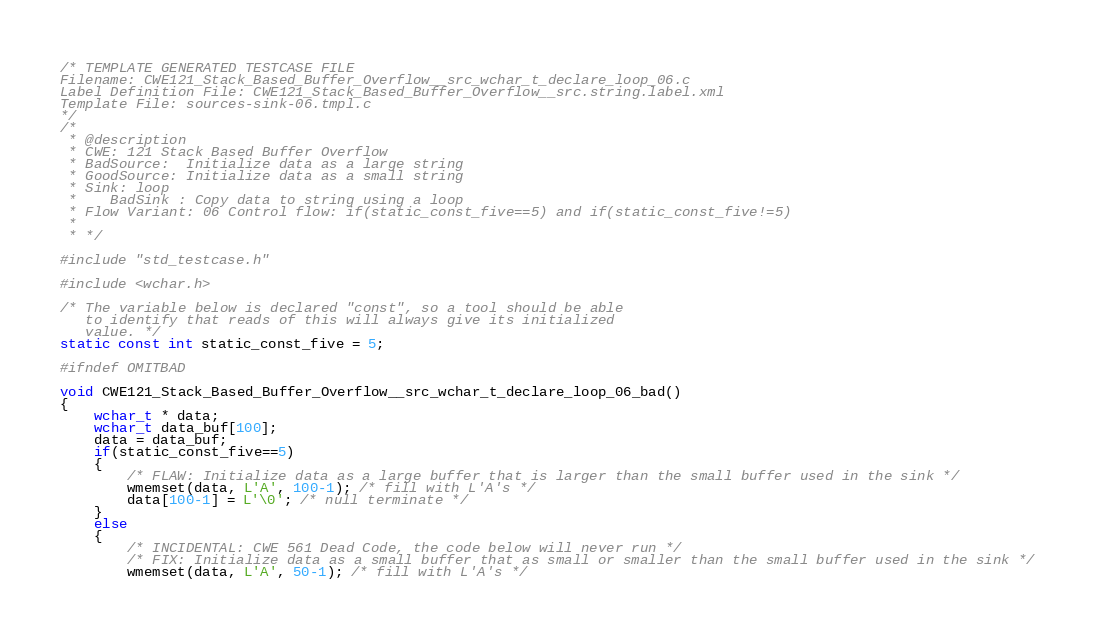<code> <loc_0><loc_0><loc_500><loc_500><_C_>/* TEMPLATE GENERATED TESTCASE FILE
Filename: CWE121_Stack_Based_Buffer_Overflow__src_wchar_t_declare_loop_06.c
Label Definition File: CWE121_Stack_Based_Buffer_Overflow__src.string.label.xml
Template File: sources-sink-06.tmpl.c
*/
/*
 * @description
 * CWE: 121 Stack Based Buffer Overflow
 * BadSource:  Initialize data as a large string
 * GoodSource: Initialize data as a small string
 * Sink: loop
 *    BadSink : Copy data to string using a loop
 * Flow Variant: 06 Control flow: if(static_const_five==5) and if(static_const_five!=5)
 *
 * */

#include "std_testcase.h"

#include <wchar.h>

/* The variable below is declared "const", so a tool should be able
   to identify that reads of this will always give its initialized
   value. */
static const int static_const_five = 5;

#ifndef OMITBAD

void CWE121_Stack_Based_Buffer_Overflow__src_wchar_t_declare_loop_06_bad()
{
    wchar_t * data;
    wchar_t data_buf[100];
    data = data_buf;
    if(static_const_five==5)
    {
        /* FLAW: Initialize data as a large buffer that is larger than the small buffer used in the sink */
        wmemset(data, L'A', 100-1); /* fill with L'A's */
        data[100-1] = L'\0'; /* null terminate */
    }
    else
    {
        /* INCIDENTAL: CWE 561 Dead Code, the code below will never run */
        /* FIX: Initialize data as a small buffer that as small or smaller than the small buffer used in the sink */
        wmemset(data, L'A', 50-1); /* fill with L'A's */</code> 